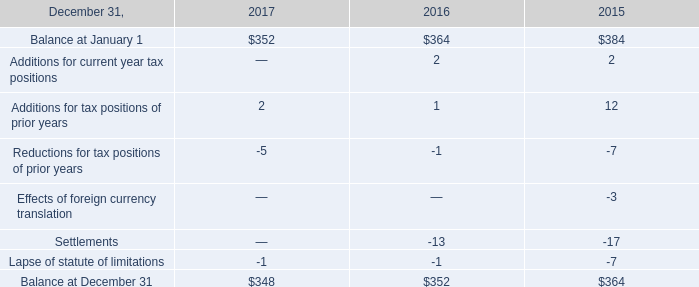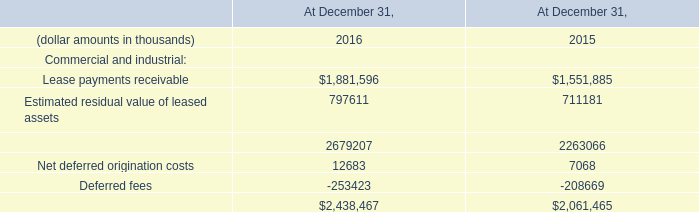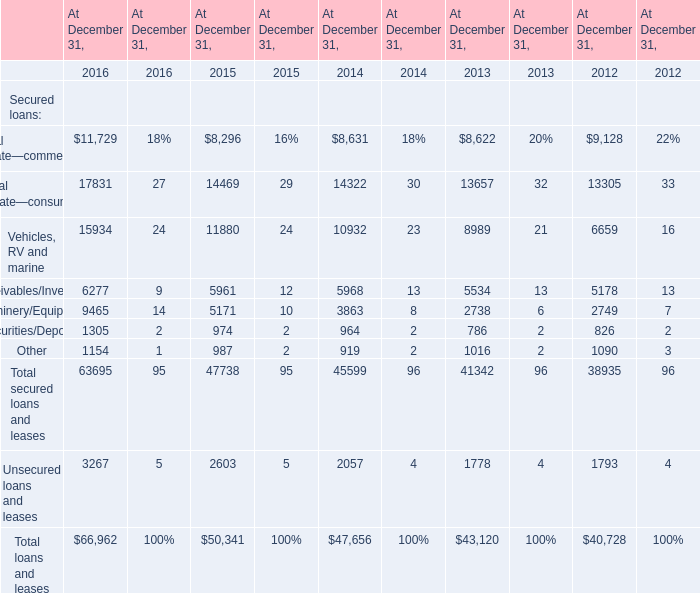What's the average of Other of At December 31, 2016, and Deferred fees of At December 31, 2016 ? 
Computations: ((1154.0 + 253423.0) / 2)
Answer: 127288.5. 